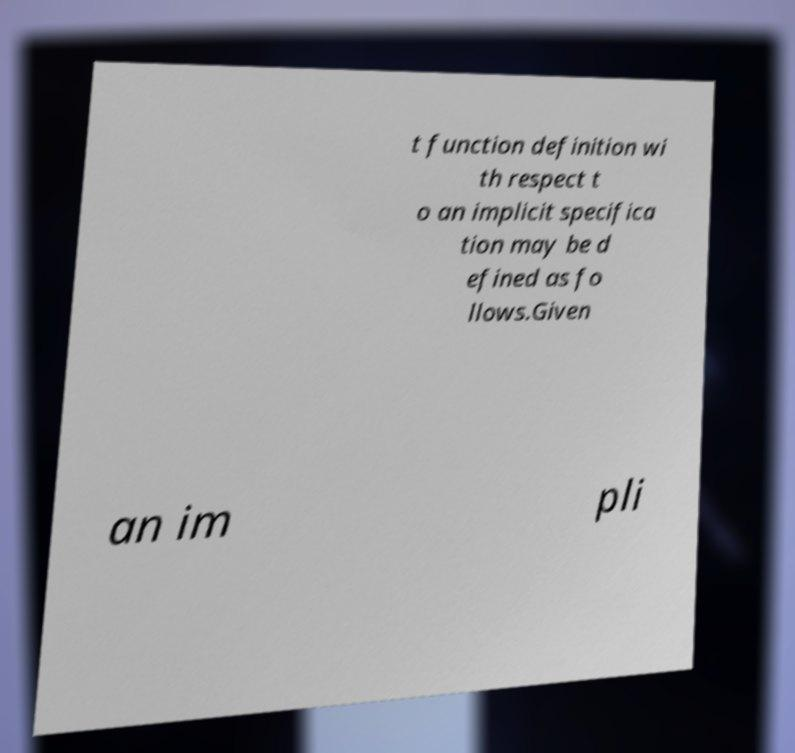What messages or text are displayed in this image? I need them in a readable, typed format. t function definition wi th respect t o an implicit specifica tion may be d efined as fo llows.Given an im pli 